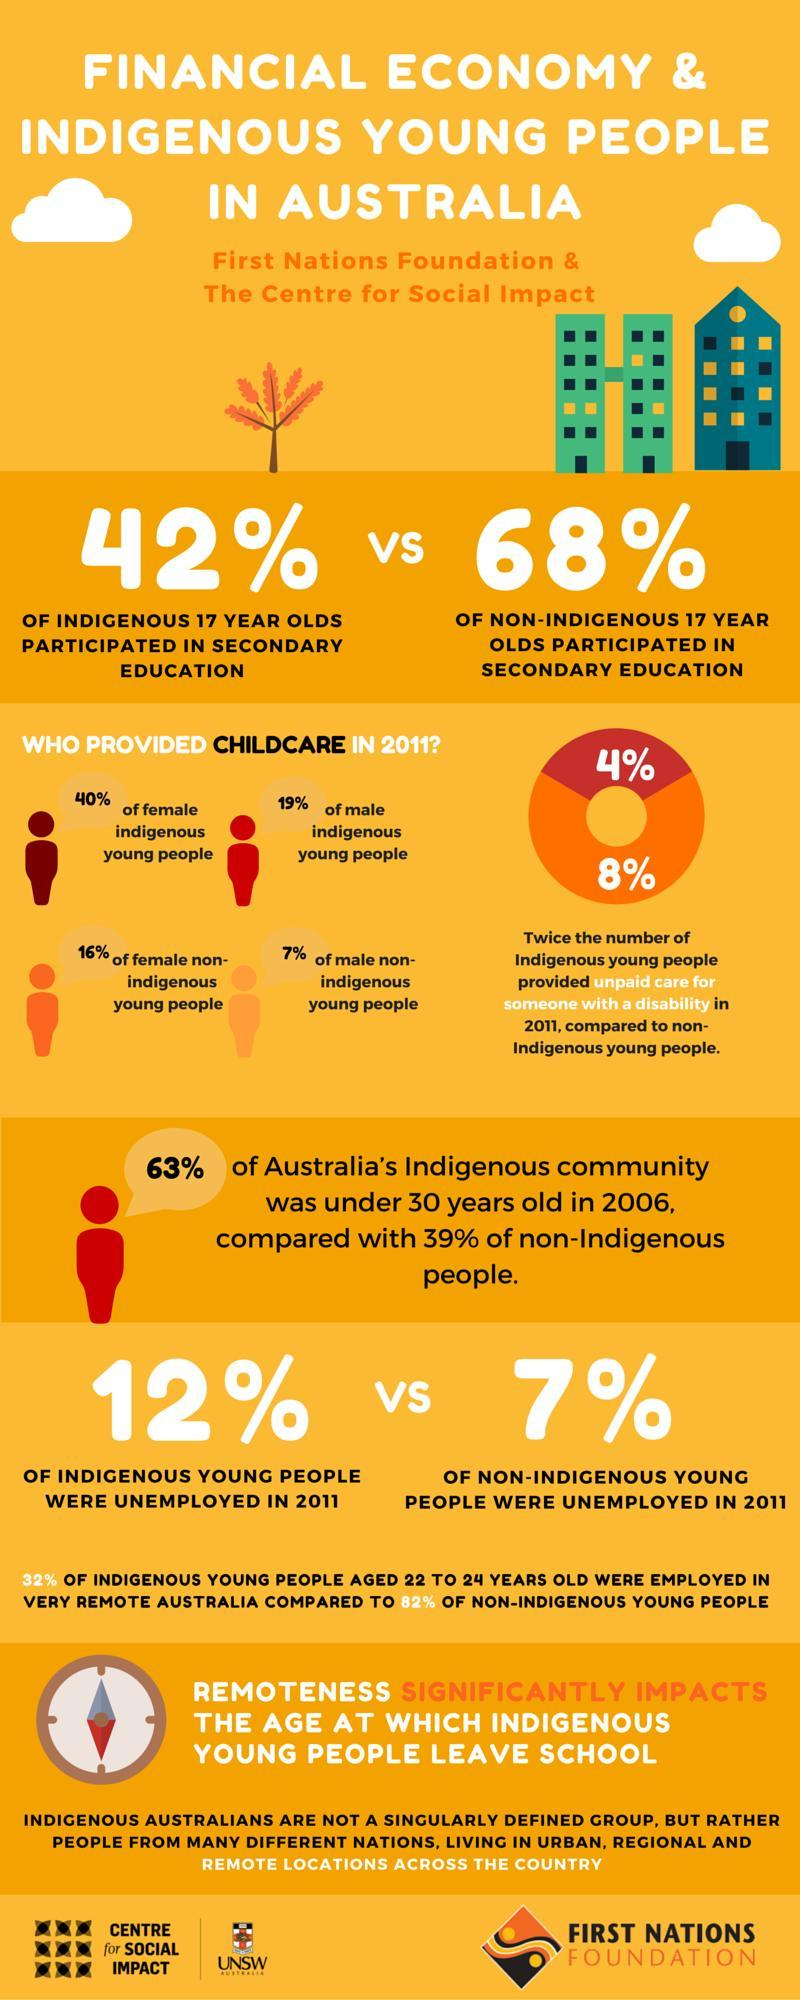What percentage of male non-indigenous young people didn't provide childcare in 2011?
Answer the question with a short phrase. 93% What percentage of non-indigenous 17-year-olds didn't participated in secondary education? 32% What percentage of indigenous 17-year-olds didn't participated in secondary education? 58% What percentage of male indigenous young people didn't provide childcare in 2011? 81% What percentage of female non-indigenous young people didn't provide childcare in 2011? 84% What percentage of female indigenous young people didn't provide childcare in 2011? 60% What percentage of indigenous young people employed in 2011? 88% What percentage of non-indigenous young people employed in 2011? 93% 